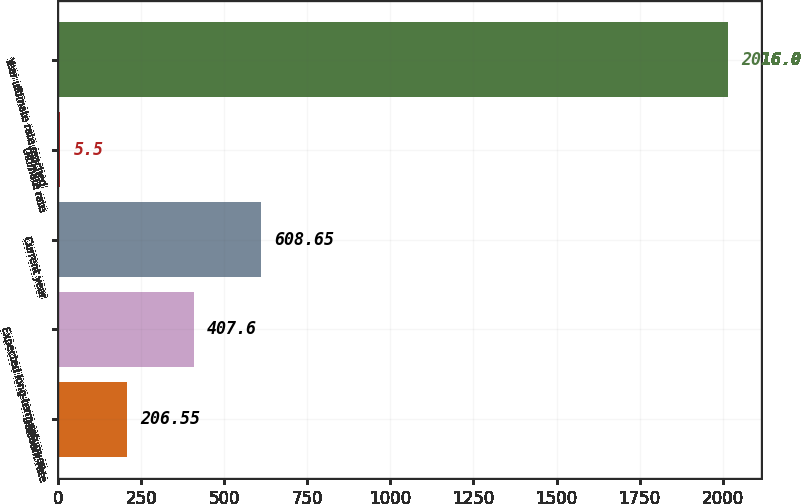Convert chart. <chart><loc_0><loc_0><loc_500><loc_500><bar_chart><fcel>Discount rate<fcel>Expected long-term return on<fcel>Current year<fcel>Ultimate rate<fcel>Year ultimate rate reached<nl><fcel>206.55<fcel>407.6<fcel>608.65<fcel>5.5<fcel>2016<nl></chart> 